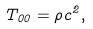Convert formula to latex. <formula><loc_0><loc_0><loc_500><loc_500>T _ { 0 0 } = \rho c ^ { 2 } ,</formula> 